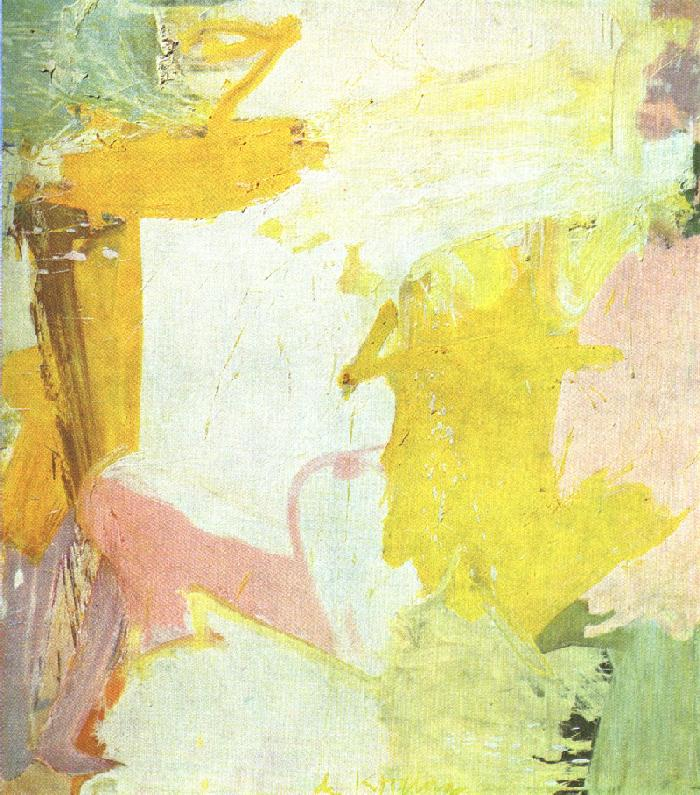Could this painting reflect a specific moment in time? If so, describe it. Yes, this painting could reflect the fleeting moment when dawn breaks and the first light of day gently illuminates the landscape. The soft pastel colors capture the delicate hues of the early morning sky, while the abstract forms represent the blurred shapes of the world as it awakens. This moment is characterized by calmness and tranquility, with a sense of new beginnings and the promise of a fresh start. The painting beautifully encapsulates this ephemeral, almost magical, moment in time. How might this painting change if it were created at a different time of day? If this painting were created at a different time of day, the color palette and overall mood might change significantly. Midday might bring brighter, more vibrant colors like bold yellows, clear blues, and intense pinks, reflecting the energy and activity of the peak daylight hours. The brushstrokes could become more defined, capturing the sharpness and intensity of noon light. Conversely, if the painting depicted dusk, the colors might shift to deeper shades of orange, purple, and pink, with elongated shadows and a sense of calm and reflection as the day winds down. The abstract forms might take on a more contemplative, serene quality, mirroring the quietness of the evening. 